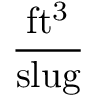<formula> <loc_0><loc_0><loc_500><loc_500>\frac { f t ^ { 3 } } { s l u g }</formula> 